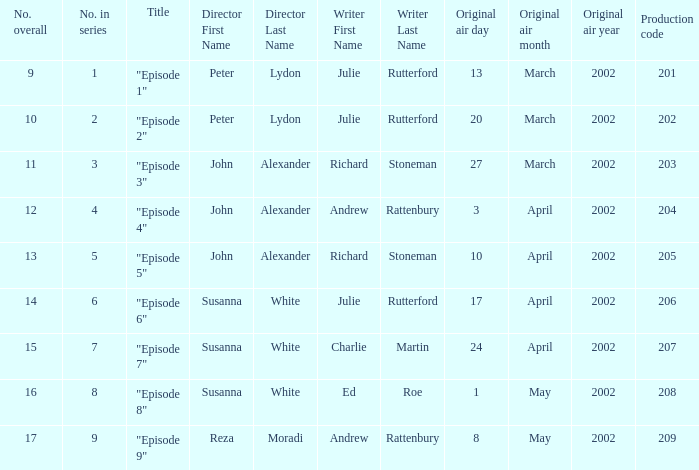When the series has 1 as its number, who serves as the director? Peter Lydon. 